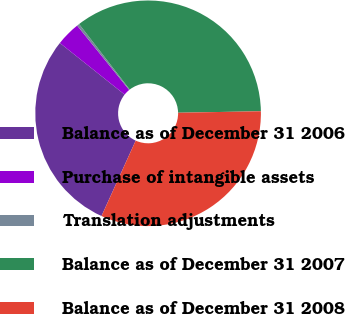<chart> <loc_0><loc_0><loc_500><loc_500><pie_chart><fcel>Balance as of December 31 2006<fcel>Purchase of intangible assets<fcel>Translation adjustments<fcel>Balance as of December 31 2007<fcel>Balance as of December 31 2008<nl><fcel>28.93%<fcel>3.47%<fcel>0.35%<fcel>35.18%<fcel>32.06%<nl></chart> 